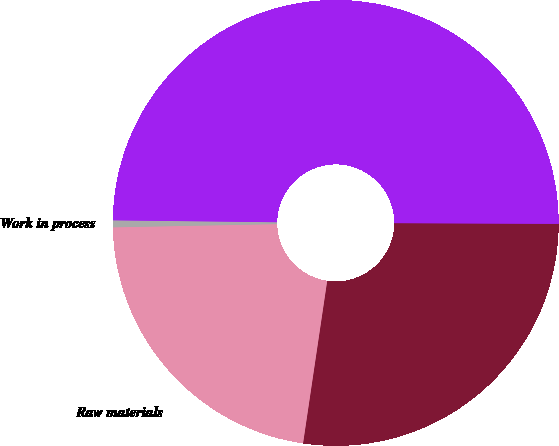<chart> <loc_0><loc_0><loc_500><loc_500><pie_chart><fcel>Finished goods<fcel>Raw materials<fcel>Work in process<fcel>Total<nl><fcel>27.28%<fcel>22.34%<fcel>0.5%<fcel>49.88%<nl></chart> 